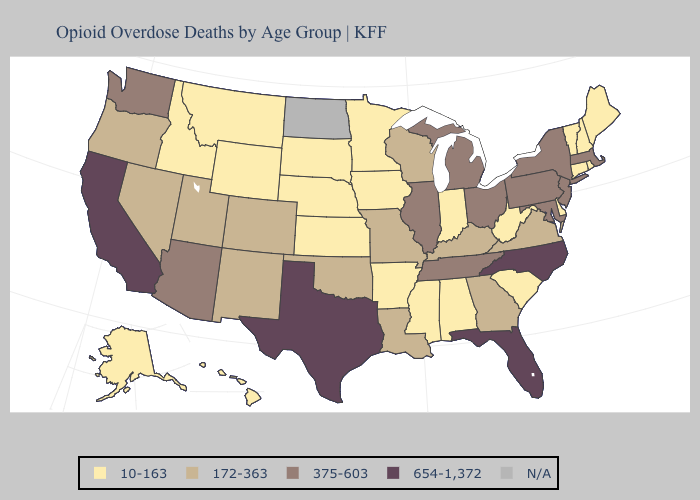Which states have the highest value in the USA?
Be succinct. California, Florida, North Carolina, Texas. Name the states that have a value in the range 172-363?
Short answer required. Colorado, Georgia, Kentucky, Louisiana, Missouri, Nevada, New Mexico, Oklahoma, Oregon, Utah, Virginia, Wisconsin. Among the states that border Washington , which have the highest value?
Concise answer only. Oregon. Among the states that border Missouri , which have the highest value?
Quick response, please. Illinois, Tennessee. Name the states that have a value in the range N/A?
Quick response, please. North Dakota. Name the states that have a value in the range 172-363?
Short answer required. Colorado, Georgia, Kentucky, Louisiana, Missouri, Nevada, New Mexico, Oklahoma, Oregon, Utah, Virginia, Wisconsin. What is the value of Alabama?
Be succinct. 10-163. Name the states that have a value in the range N/A?
Give a very brief answer. North Dakota. What is the lowest value in states that border Oklahoma?
Be succinct. 10-163. Name the states that have a value in the range 654-1,372?
Answer briefly. California, Florida, North Carolina, Texas. What is the highest value in the Northeast ?
Write a very short answer. 375-603. What is the value of Ohio?
Be succinct. 375-603. Name the states that have a value in the range 375-603?
Write a very short answer. Arizona, Illinois, Maryland, Massachusetts, Michigan, New Jersey, New York, Ohio, Pennsylvania, Tennessee, Washington. Name the states that have a value in the range 654-1,372?
Short answer required. California, Florida, North Carolina, Texas. Name the states that have a value in the range 10-163?
Short answer required. Alabama, Alaska, Arkansas, Connecticut, Delaware, Hawaii, Idaho, Indiana, Iowa, Kansas, Maine, Minnesota, Mississippi, Montana, Nebraska, New Hampshire, Rhode Island, South Carolina, South Dakota, Vermont, West Virginia, Wyoming. 